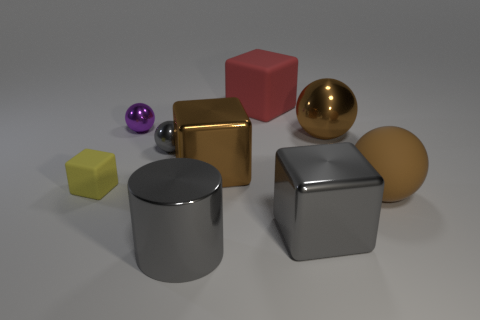Subtract all brown cubes. How many cubes are left? 3 Subtract all big brown rubber balls. How many balls are left? 3 Subtract 1 purple balls. How many objects are left? 8 Subtract all cubes. How many objects are left? 5 Subtract 3 cubes. How many cubes are left? 1 Subtract all brown balls. Subtract all purple cylinders. How many balls are left? 2 Subtract all gray blocks. How many purple balls are left? 1 Subtract all large purple cubes. Subtract all matte blocks. How many objects are left? 7 Add 7 big matte spheres. How many big matte spheres are left? 8 Add 7 rubber cubes. How many rubber cubes exist? 9 